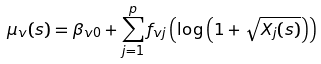Convert formula to latex. <formula><loc_0><loc_0><loc_500><loc_500>\mu _ { v } ( s ) = \beta _ { v 0 } + \sum _ { j = 1 } ^ { p } f _ { v j } \left ( \log \left ( 1 + \sqrt { X _ { j } ( s ) } \right ) \right )</formula> 